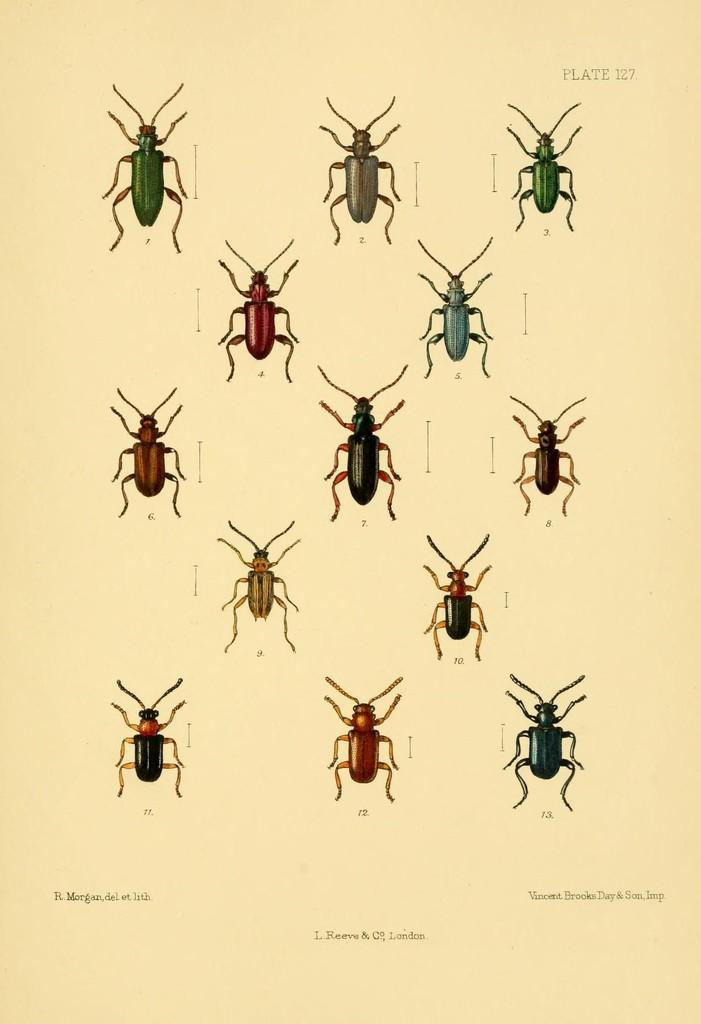What is the main subject of the image? The main subject of the image is a paper. What is depicted on the paper? There are images of beetles on the paper. Is there any text on the paper? Yes, there is text at the bottom of the paper. What type of eggnog is being served during the holiday game depicted on the paper? There is no eggnog, holiday, or game depicted on the paper; it only contains images of beetles and text. 